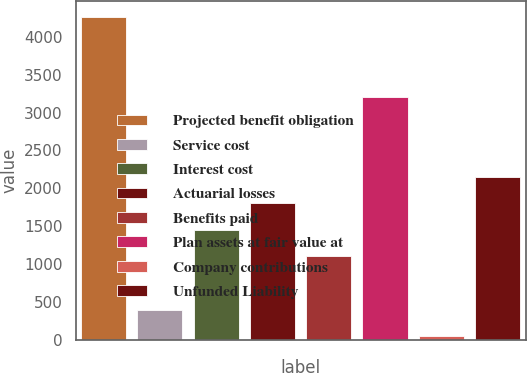<chart> <loc_0><loc_0><loc_500><loc_500><bar_chart><fcel>Projected benefit obligation<fcel>Service cost<fcel>Interest cost<fcel>Actuarial losses<fcel>Benefits paid<fcel>Plan assets at fair value at<fcel>Company contributions<fcel>Unfunded Liability<nl><fcel>4259<fcel>403.5<fcel>1455<fcel>1805.5<fcel>1104.5<fcel>3207.5<fcel>53<fcel>2156<nl></chart> 